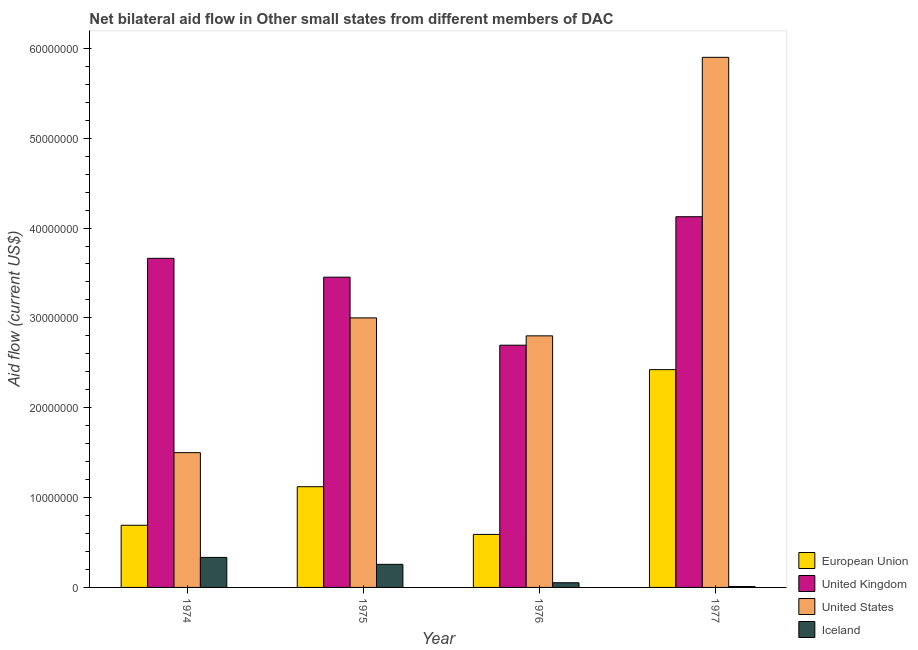Are the number of bars on each tick of the X-axis equal?
Your answer should be very brief. Yes. How many bars are there on the 3rd tick from the right?
Make the answer very short. 4. What is the label of the 2nd group of bars from the left?
Provide a succinct answer. 1975. What is the amount of aid given by eu in 1974?
Provide a succinct answer. 6.92e+06. Across all years, what is the maximum amount of aid given by us?
Provide a succinct answer. 5.90e+07. Across all years, what is the minimum amount of aid given by iceland?
Your response must be concise. 1.00e+05. In which year was the amount of aid given by uk minimum?
Ensure brevity in your answer.  1976. What is the total amount of aid given by iceland in the graph?
Offer a terse response. 6.53e+06. What is the difference between the amount of aid given by uk in 1974 and that in 1976?
Ensure brevity in your answer.  9.67e+06. What is the difference between the amount of aid given by uk in 1977 and the amount of aid given by eu in 1975?
Your response must be concise. 6.73e+06. What is the average amount of aid given by us per year?
Your response must be concise. 3.30e+07. In the year 1974, what is the difference between the amount of aid given by iceland and amount of aid given by uk?
Provide a short and direct response. 0. In how many years, is the amount of aid given by uk greater than 22000000 US$?
Provide a short and direct response. 4. What is the ratio of the amount of aid given by uk in 1974 to that in 1975?
Keep it short and to the point. 1.06. Is the amount of aid given by iceland in 1974 less than that in 1975?
Your answer should be compact. No. Is the difference between the amount of aid given by eu in 1974 and 1976 greater than the difference between the amount of aid given by iceland in 1974 and 1976?
Offer a terse response. No. What is the difference between the highest and the second highest amount of aid given by eu?
Provide a short and direct response. 1.30e+07. What is the difference between the highest and the lowest amount of aid given by iceland?
Offer a very short reply. 3.24e+06. Is the sum of the amount of aid given by uk in 1974 and 1975 greater than the maximum amount of aid given by us across all years?
Your answer should be very brief. Yes. Is it the case that in every year, the sum of the amount of aid given by iceland and amount of aid given by eu is greater than the sum of amount of aid given by uk and amount of aid given by us?
Provide a succinct answer. No. What does the 2nd bar from the left in 1977 represents?
Your answer should be compact. United Kingdom. How many bars are there?
Your response must be concise. 16. What is the difference between two consecutive major ticks on the Y-axis?
Your answer should be very brief. 1.00e+07. Are the values on the major ticks of Y-axis written in scientific E-notation?
Provide a succinct answer. No. Does the graph contain grids?
Your response must be concise. No. Where does the legend appear in the graph?
Your answer should be very brief. Bottom right. How many legend labels are there?
Offer a terse response. 4. What is the title of the graph?
Your answer should be very brief. Net bilateral aid flow in Other small states from different members of DAC. What is the Aid flow (current US$) in European Union in 1974?
Your answer should be compact. 6.92e+06. What is the Aid flow (current US$) of United Kingdom in 1974?
Give a very brief answer. 3.66e+07. What is the Aid flow (current US$) of United States in 1974?
Ensure brevity in your answer.  1.50e+07. What is the Aid flow (current US$) in Iceland in 1974?
Make the answer very short. 3.34e+06. What is the Aid flow (current US$) of European Union in 1975?
Make the answer very short. 1.12e+07. What is the Aid flow (current US$) of United Kingdom in 1975?
Make the answer very short. 3.45e+07. What is the Aid flow (current US$) of United States in 1975?
Your response must be concise. 3.00e+07. What is the Aid flow (current US$) in Iceland in 1975?
Your response must be concise. 2.57e+06. What is the Aid flow (current US$) in European Union in 1976?
Your answer should be very brief. 5.90e+06. What is the Aid flow (current US$) of United Kingdom in 1976?
Ensure brevity in your answer.  2.70e+07. What is the Aid flow (current US$) in United States in 1976?
Keep it short and to the point. 2.80e+07. What is the Aid flow (current US$) of Iceland in 1976?
Give a very brief answer. 5.20e+05. What is the Aid flow (current US$) of European Union in 1977?
Your answer should be very brief. 2.42e+07. What is the Aid flow (current US$) of United Kingdom in 1977?
Keep it short and to the point. 4.13e+07. What is the Aid flow (current US$) in United States in 1977?
Provide a short and direct response. 5.90e+07. What is the Aid flow (current US$) in Iceland in 1977?
Give a very brief answer. 1.00e+05. Across all years, what is the maximum Aid flow (current US$) in European Union?
Give a very brief answer. 2.42e+07. Across all years, what is the maximum Aid flow (current US$) of United Kingdom?
Provide a succinct answer. 4.13e+07. Across all years, what is the maximum Aid flow (current US$) of United States?
Your answer should be very brief. 5.90e+07. Across all years, what is the maximum Aid flow (current US$) in Iceland?
Offer a terse response. 3.34e+06. Across all years, what is the minimum Aid flow (current US$) in European Union?
Your response must be concise. 5.90e+06. Across all years, what is the minimum Aid flow (current US$) in United Kingdom?
Give a very brief answer. 2.70e+07. Across all years, what is the minimum Aid flow (current US$) of United States?
Your answer should be compact. 1.50e+07. Across all years, what is the minimum Aid flow (current US$) in Iceland?
Provide a short and direct response. 1.00e+05. What is the total Aid flow (current US$) in European Union in the graph?
Offer a terse response. 4.83e+07. What is the total Aid flow (current US$) of United Kingdom in the graph?
Your answer should be compact. 1.39e+08. What is the total Aid flow (current US$) in United States in the graph?
Keep it short and to the point. 1.32e+08. What is the total Aid flow (current US$) of Iceland in the graph?
Provide a short and direct response. 6.53e+06. What is the difference between the Aid flow (current US$) in European Union in 1974 and that in 1975?
Your response must be concise. -4.29e+06. What is the difference between the Aid flow (current US$) of United Kingdom in 1974 and that in 1975?
Keep it short and to the point. 2.10e+06. What is the difference between the Aid flow (current US$) in United States in 1974 and that in 1975?
Your answer should be very brief. -1.50e+07. What is the difference between the Aid flow (current US$) in Iceland in 1974 and that in 1975?
Offer a very short reply. 7.70e+05. What is the difference between the Aid flow (current US$) of European Union in 1974 and that in 1976?
Give a very brief answer. 1.02e+06. What is the difference between the Aid flow (current US$) in United Kingdom in 1974 and that in 1976?
Ensure brevity in your answer.  9.67e+06. What is the difference between the Aid flow (current US$) in United States in 1974 and that in 1976?
Your response must be concise. -1.30e+07. What is the difference between the Aid flow (current US$) of Iceland in 1974 and that in 1976?
Your response must be concise. 2.82e+06. What is the difference between the Aid flow (current US$) in European Union in 1974 and that in 1977?
Ensure brevity in your answer.  -1.73e+07. What is the difference between the Aid flow (current US$) of United Kingdom in 1974 and that in 1977?
Offer a terse response. -4.63e+06. What is the difference between the Aid flow (current US$) in United States in 1974 and that in 1977?
Your answer should be very brief. -4.40e+07. What is the difference between the Aid flow (current US$) in Iceland in 1974 and that in 1977?
Make the answer very short. 3.24e+06. What is the difference between the Aid flow (current US$) in European Union in 1975 and that in 1976?
Your response must be concise. 5.31e+06. What is the difference between the Aid flow (current US$) of United Kingdom in 1975 and that in 1976?
Make the answer very short. 7.57e+06. What is the difference between the Aid flow (current US$) in United States in 1975 and that in 1976?
Offer a terse response. 2.00e+06. What is the difference between the Aid flow (current US$) of Iceland in 1975 and that in 1976?
Ensure brevity in your answer.  2.05e+06. What is the difference between the Aid flow (current US$) of European Union in 1975 and that in 1977?
Offer a very short reply. -1.30e+07. What is the difference between the Aid flow (current US$) in United Kingdom in 1975 and that in 1977?
Your answer should be compact. -6.73e+06. What is the difference between the Aid flow (current US$) in United States in 1975 and that in 1977?
Provide a succinct answer. -2.90e+07. What is the difference between the Aid flow (current US$) of Iceland in 1975 and that in 1977?
Your response must be concise. 2.47e+06. What is the difference between the Aid flow (current US$) of European Union in 1976 and that in 1977?
Your answer should be very brief. -1.83e+07. What is the difference between the Aid flow (current US$) in United Kingdom in 1976 and that in 1977?
Give a very brief answer. -1.43e+07. What is the difference between the Aid flow (current US$) of United States in 1976 and that in 1977?
Keep it short and to the point. -3.10e+07. What is the difference between the Aid flow (current US$) of Iceland in 1976 and that in 1977?
Ensure brevity in your answer.  4.20e+05. What is the difference between the Aid flow (current US$) in European Union in 1974 and the Aid flow (current US$) in United Kingdom in 1975?
Your response must be concise. -2.76e+07. What is the difference between the Aid flow (current US$) of European Union in 1974 and the Aid flow (current US$) of United States in 1975?
Your response must be concise. -2.31e+07. What is the difference between the Aid flow (current US$) in European Union in 1974 and the Aid flow (current US$) in Iceland in 1975?
Offer a terse response. 4.35e+06. What is the difference between the Aid flow (current US$) of United Kingdom in 1974 and the Aid flow (current US$) of United States in 1975?
Keep it short and to the point. 6.63e+06. What is the difference between the Aid flow (current US$) in United Kingdom in 1974 and the Aid flow (current US$) in Iceland in 1975?
Provide a short and direct response. 3.41e+07. What is the difference between the Aid flow (current US$) of United States in 1974 and the Aid flow (current US$) of Iceland in 1975?
Your response must be concise. 1.24e+07. What is the difference between the Aid flow (current US$) in European Union in 1974 and the Aid flow (current US$) in United Kingdom in 1976?
Make the answer very short. -2.00e+07. What is the difference between the Aid flow (current US$) of European Union in 1974 and the Aid flow (current US$) of United States in 1976?
Your response must be concise. -2.11e+07. What is the difference between the Aid flow (current US$) in European Union in 1974 and the Aid flow (current US$) in Iceland in 1976?
Provide a short and direct response. 6.40e+06. What is the difference between the Aid flow (current US$) of United Kingdom in 1974 and the Aid flow (current US$) of United States in 1976?
Offer a terse response. 8.63e+06. What is the difference between the Aid flow (current US$) in United Kingdom in 1974 and the Aid flow (current US$) in Iceland in 1976?
Your answer should be very brief. 3.61e+07. What is the difference between the Aid flow (current US$) in United States in 1974 and the Aid flow (current US$) in Iceland in 1976?
Provide a short and direct response. 1.45e+07. What is the difference between the Aid flow (current US$) of European Union in 1974 and the Aid flow (current US$) of United Kingdom in 1977?
Provide a succinct answer. -3.43e+07. What is the difference between the Aid flow (current US$) of European Union in 1974 and the Aid flow (current US$) of United States in 1977?
Give a very brief answer. -5.21e+07. What is the difference between the Aid flow (current US$) in European Union in 1974 and the Aid flow (current US$) in Iceland in 1977?
Keep it short and to the point. 6.82e+06. What is the difference between the Aid flow (current US$) of United Kingdom in 1974 and the Aid flow (current US$) of United States in 1977?
Offer a terse response. -2.24e+07. What is the difference between the Aid flow (current US$) of United Kingdom in 1974 and the Aid flow (current US$) of Iceland in 1977?
Offer a terse response. 3.65e+07. What is the difference between the Aid flow (current US$) of United States in 1974 and the Aid flow (current US$) of Iceland in 1977?
Provide a succinct answer. 1.49e+07. What is the difference between the Aid flow (current US$) in European Union in 1975 and the Aid flow (current US$) in United Kingdom in 1976?
Offer a very short reply. -1.58e+07. What is the difference between the Aid flow (current US$) of European Union in 1975 and the Aid flow (current US$) of United States in 1976?
Ensure brevity in your answer.  -1.68e+07. What is the difference between the Aid flow (current US$) of European Union in 1975 and the Aid flow (current US$) of Iceland in 1976?
Your answer should be very brief. 1.07e+07. What is the difference between the Aid flow (current US$) of United Kingdom in 1975 and the Aid flow (current US$) of United States in 1976?
Provide a short and direct response. 6.53e+06. What is the difference between the Aid flow (current US$) in United Kingdom in 1975 and the Aid flow (current US$) in Iceland in 1976?
Ensure brevity in your answer.  3.40e+07. What is the difference between the Aid flow (current US$) of United States in 1975 and the Aid flow (current US$) of Iceland in 1976?
Provide a short and direct response. 2.95e+07. What is the difference between the Aid flow (current US$) of European Union in 1975 and the Aid flow (current US$) of United Kingdom in 1977?
Keep it short and to the point. -3.00e+07. What is the difference between the Aid flow (current US$) in European Union in 1975 and the Aid flow (current US$) in United States in 1977?
Ensure brevity in your answer.  -4.78e+07. What is the difference between the Aid flow (current US$) in European Union in 1975 and the Aid flow (current US$) in Iceland in 1977?
Provide a succinct answer. 1.11e+07. What is the difference between the Aid flow (current US$) of United Kingdom in 1975 and the Aid flow (current US$) of United States in 1977?
Provide a succinct answer. -2.45e+07. What is the difference between the Aid flow (current US$) of United Kingdom in 1975 and the Aid flow (current US$) of Iceland in 1977?
Ensure brevity in your answer.  3.44e+07. What is the difference between the Aid flow (current US$) in United States in 1975 and the Aid flow (current US$) in Iceland in 1977?
Your answer should be compact. 2.99e+07. What is the difference between the Aid flow (current US$) in European Union in 1976 and the Aid flow (current US$) in United Kingdom in 1977?
Offer a very short reply. -3.54e+07. What is the difference between the Aid flow (current US$) in European Union in 1976 and the Aid flow (current US$) in United States in 1977?
Offer a terse response. -5.31e+07. What is the difference between the Aid flow (current US$) of European Union in 1976 and the Aid flow (current US$) of Iceland in 1977?
Ensure brevity in your answer.  5.80e+06. What is the difference between the Aid flow (current US$) of United Kingdom in 1976 and the Aid flow (current US$) of United States in 1977?
Make the answer very short. -3.20e+07. What is the difference between the Aid flow (current US$) in United Kingdom in 1976 and the Aid flow (current US$) in Iceland in 1977?
Your answer should be very brief. 2.69e+07. What is the difference between the Aid flow (current US$) in United States in 1976 and the Aid flow (current US$) in Iceland in 1977?
Your answer should be compact. 2.79e+07. What is the average Aid flow (current US$) of European Union per year?
Your response must be concise. 1.21e+07. What is the average Aid flow (current US$) in United Kingdom per year?
Offer a very short reply. 3.48e+07. What is the average Aid flow (current US$) of United States per year?
Your response must be concise. 3.30e+07. What is the average Aid flow (current US$) in Iceland per year?
Keep it short and to the point. 1.63e+06. In the year 1974, what is the difference between the Aid flow (current US$) in European Union and Aid flow (current US$) in United Kingdom?
Make the answer very short. -2.97e+07. In the year 1974, what is the difference between the Aid flow (current US$) of European Union and Aid flow (current US$) of United States?
Make the answer very short. -8.08e+06. In the year 1974, what is the difference between the Aid flow (current US$) in European Union and Aid flow (current US$) in Iceland?
Your answer should be very brief. 3.58e+06. In the year 1974, what is the difference between the Aid flow (current US$) in United Kingdom and Aid flow (current US$) in United States?
Give a very brief answer. 2.16e+07. In the year 1974, what is the difference between the Aid flow (current US$) in United Kingdom and Aid flow (current US$) in Iceland?
Your response must be concise. 3.33e+07. In the year 1974, what is the difference between the Aid flow (current US$) of United States and Aid flow (current US$) of Iceland?
Provide a short and direct response. 1.17e+07. In the year 1975, what is the difference between the Aid flow (current US$) of European Union and Aid flow (current US$) of United Kingdom?
Your answer should be very brief. -2.33e+07. In the year 1975, what is the difference between the Aid flow (current US$) in European Union and Aid flow (current US$) in United States?
Provide a succinct answer. -1.88e+07. In the year 1975, what is the difference between the Aid flow (current US$) of European Union and Aid flow (current US$) of Iceland?
Ensure brevity in your answer.  8.64e+06. In the year 1975, what is the difference between the Aid flow (current US$) of United Kingdom and Aid flow (current US$) of United States?
Keep it short and to the point. 4.53e+06. In the year 1975, what is the difference between the Aid flow (current US$) of United Kingdom and Aid flow (current US$) of Iceland?
Provide a succinct answer. 3.20e+07. In the year 1975, what is the difference between the Aid flow (current US$) of United States and Aid flow (current US$) of Iceland?
Offer a terse response. 2.74e+07. In the year 1976, what is the difference between the Aid flow (current US$) of European Union and Aid flow (current US$) of United Kingdom?
Your answer should be compact. -2.11e+07. In the year 1976, what is the difference between the Aid flow (current US$) of European Union and Aid flow (current US$) of United States?
Offer a terse response. -2.21e+07. In the year 1976, what is the difference between the Aid flow (current US$) in European Union and Aid flow (current US$) in Iceland?
Offer a very short reply. 5.38e+06. In the year 1976, what is the difference between the Aid flow (current US$) of United Kingdom and Aid flow (current US$) of United States?
Provide a succinct answer. -1.04e+06. In the year 1976, what is the difference between the Aid flow (current US$) of United Kingdom and Aid flow (current US$) of Iceland?
Your answer should be compact. 2.64e+07. In the year 1976, what is the difference between the Aid flow (current US$) of United States and Aid flow (current US$) of Iceland?
Give a very brief answer. 2.75e+07. In the year 1977, what is the difference between the Aid flow (current US$) in European Union and Aid flow (current US$) in United Kingdom?
Your answer should be compact. -1.70e+07. In the year 1977, what is the difference between the Aid flow (current US$) of European Union and Aid flow (current US$) of United States?
Keep it short and to the point. -3.48e+07. In the year 1977, what is the difference between the Aid flow (current US$) in European Union and Aid flow (current US$) in Iceland?
Offer a terse response. 2.41e+07. In the year 1977, what is the difference between the Aid flow (current US$) in United Kingdom and Aid flow (current US$) in United States?
Offer a very short reply. -1.77e+07. In the year 1977, what is the difference between the Aid flow (current US$) of United Kingdom and Aid flow (current US$) of Iceland?
Ensure brevity in your answer.  4.12e+07. In the year 1977, what is the difference between the Aid flow (current US$) in United States and Aid flow (current US$) in Iceland?
Provide a succinct answer. 5.89e+07. What is the ratio of the Aid flow (current US$) of European Union in 1974 to that in 1975?
Ensure brevity in your answer.  0.62. What is the ratio of the Aid flow (current US$) of United Kingdom in 1974 to that in 1975?
Provide a succinct answer. 1.06. What is the ratio of the Aid flow (current US$) in United States in 1974 to that in 1975?
Offer a terse response. 0.5. What is the ratio of the Aid flow (current US$) of Iceland in 1974 to that in 1975?
Offer a very short reply. 1.3. What is the ratio of the Aid flow (current US$) in European Union in 1974 to that in 1976?
Offer a very short reply. 1.17. What is the ratio of the Aid flow (current US$) in United Kingdom in 1974 to that in 1976?
Your answer should be very brief. 1.36. What is the ratio of the Aid flow (current US$) of United States in 1974 to that in 1976?
Offer a terse response. 0.54. What is the ratio of the Aid flow (current US$) in Iceland in 1974 to that in 1976?
Ensure brevity in your answer.  6.42. What is the ratio of the Aid flow (current US$) in European Union in 1974 to that in 1977?
Offer a terse response. 0.29. What is the ratio of the Aid flow (current US$) in United Kingdom in 1974 to that in 1977?
Your response must be concise. 0.89. What is the ratio of the Aid flow (current US$) of United States in 1974 to that in 1977?
Your answer should be very brief. 0.25. What is the ratio of the Aid flow (current US$) in Iceland in 1974 to that in 1977?
Ensure brevity in your answer.  33.4. What is the ratio of the Aid flow (current US$) in European Union in 1975 to that in 1976?
Your response must be concise. 1.9. What is the ratio of the Aid flow (current US$) in United Kingdom in 1975 to that in 1976?
Provide a short and direct response. 1.28. What is the ratio of the Aid flow (current US$) in United States in 1975 to that in 1976?
Offer a terse response. 1.07. What is the ratio of the Aid flow (current US$) in Iceland in 1975 to that in 1976?
Offer a terse response. 4.94. What is the ratio of the Aid flow (current US$) of European Union in 1975 to that in 1977?
Your answer should be very brief. 0.46. What is the ratio of the Aid flow (current US$) in United Kingdom in 1975 to that in 1977?
Your answer should be very brief. 0.84. What is the ratio of the Aid flow (current US$) of United States in 1975 to that in 1977?
Offer a terse response. 0.51. What is the ratio of the Aid flow (current US$) in Iceland in 1975 to that in 1977?
Offer a very short reply. 25.7. What is the ratio of the Aid flow (current US$) in European Union in 1976 to that in 1977?
Offer a very short reply. 0.24. What is the ratio of the Aid flow (current US$) of United Kingdom in 1976 to that in 1977?
Your answer should be very brief. 0.65. What is the ratio of the Aid flow (current US$) of United States in 1976 to that in 1977?
Provide a succinct answer. 0.47. What is the ratio of the Aid flow (current US$) of Iceland in 1976 to that in 1977?
Your answer should be compact. 5.2. What is the difference between the highest and the second highest Aid flow (current US$) of European Union?
Keep it short and to the point. 1.30e+07. What is the difference between the highest and the second highest Aid flow (current US$) in United Kingdom?
Offer a terse response. 4.63e+06. What is the difference between the highest and the second highest Aid flow (current US$) in United States?
Give a very brief answer. 2.90e+07. What is the difference between the highest and the second highest Aid flow (current US$) in Iceland?
Provide a succinct answer. 7.70e+05. What is the difference between the highest and the lowest Aid flow (current US$) of European Union?
Your response must be concise. 1.83e+07. What is the difference between the highest and the lowest Aid flow (current US$) of United Kingdom?
Ensure brevity in your answer.  1.43e+07. What is the difference between the highest and the lowest Aid flow (current US$) in United States?
Keep it short and to the point. 4.40e+07. What is the difference between the highest and the lowest Aid flow (current US$) in Iceland?
Ensure brevity in your answer.  3.24e+06. 